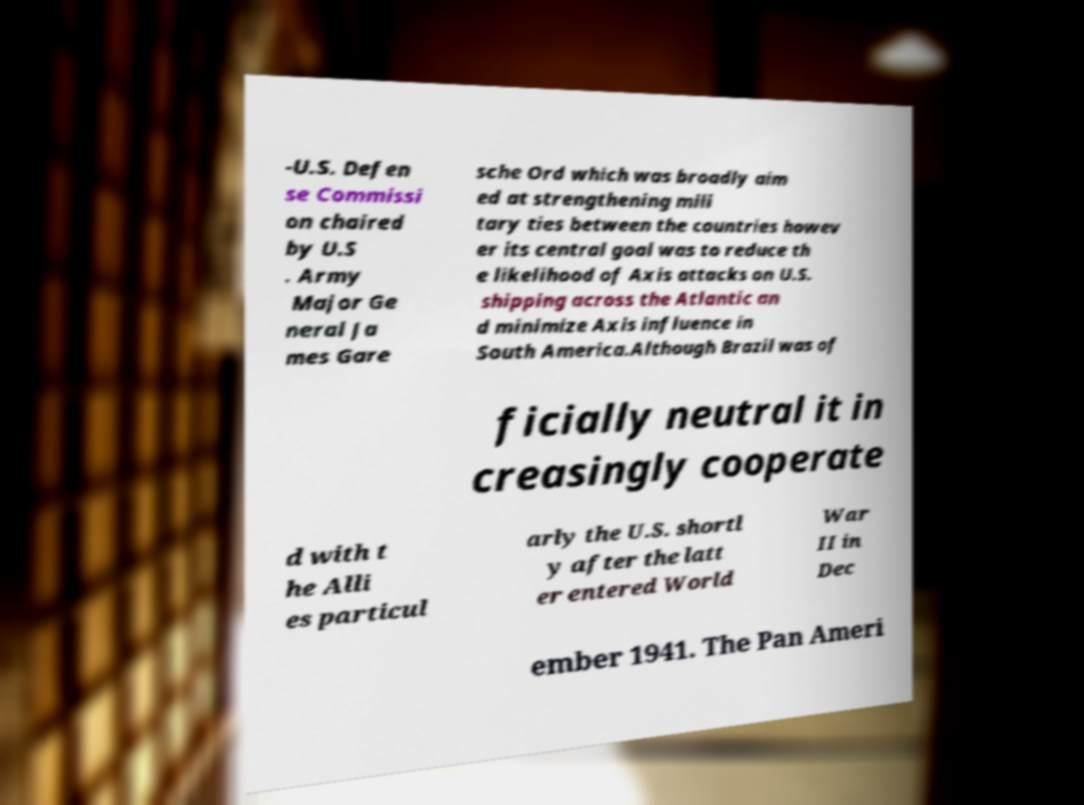I need the written content from this picture converted into text. Can you do that? -U.S. Defen se Commissi on chaired by U.S . Army Major Ge neral Ja mes Gare sche Ord which was broadly aim ed at strengthening mili tary ties between the countries howev er its central goal was to reduce th e likelihood of Axis attacks on U.S. shipping across the Atlantic an d minimize Axis influence in South America.Although Brazil was of ficially neutral it in creasingly cooperate d with t he Alli es particul arly the U.S. shortl y after the latt er entered World War II in Dec ember 1941. The Pan Ameri 